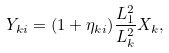Convert formula to latex. <formula><loc_0><loc_0><loc_500><loc_500>Y _ { k i } = ( 1 + \eta _ { k i } ) \frac { L _ { 1 } ^ { 2 } } { L _ { k } ^ { 2 } } X _ { k } ,</formula> 